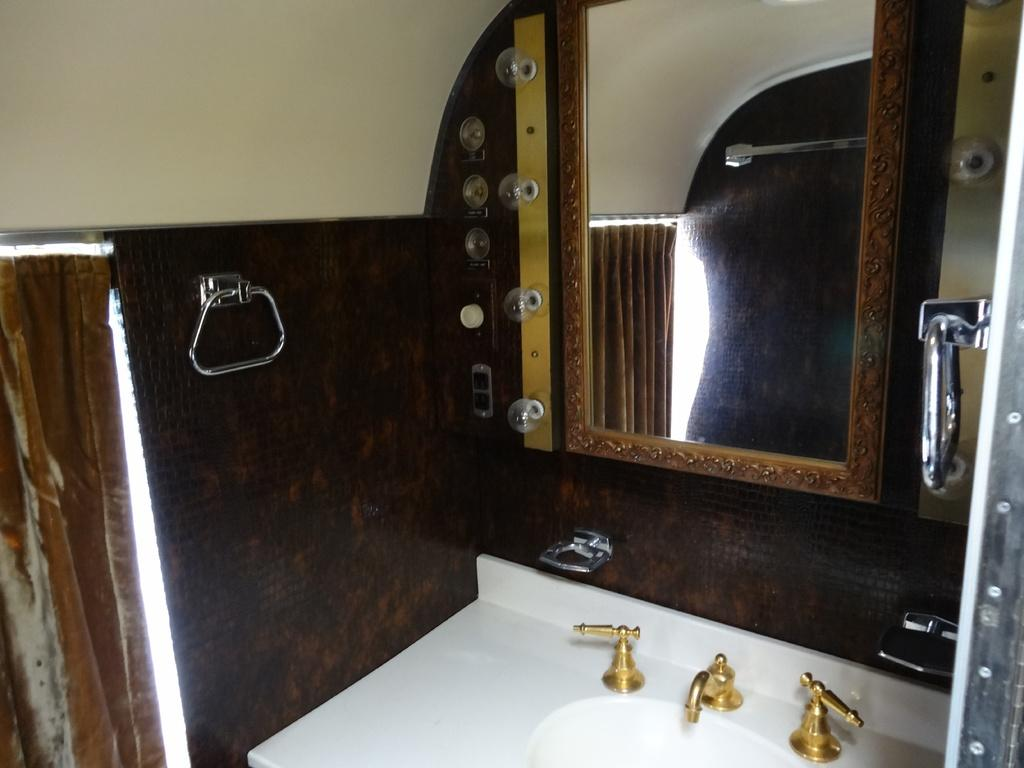What can be found in the image for washing hands? There is a wash basin in the image. How many taps are connected to the wash basin? There are three taps connected to the wash basin. What can be used for personal grooming in the image? There is a mirror in the image. How many stands are present in the image? There are three stands in the image. What type of apparatus is used to pull the wash basin closer to the mirror? There is no apparatus present in the image for pulling the wash basin closer to the mirror. The wash basin and mirror are stationary objects. 